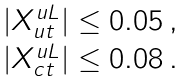Convert formula to latex. <formula><loc_0><loc_0><loc_500><loc_500>\begin{array} { c } | X ^ { u L } _ { u t } | \leq 0 . 0 5 \, , \\ | X ^ { u L } _ { c t } | \leq 0 . 0 8 \, . \end{array}</formula> 